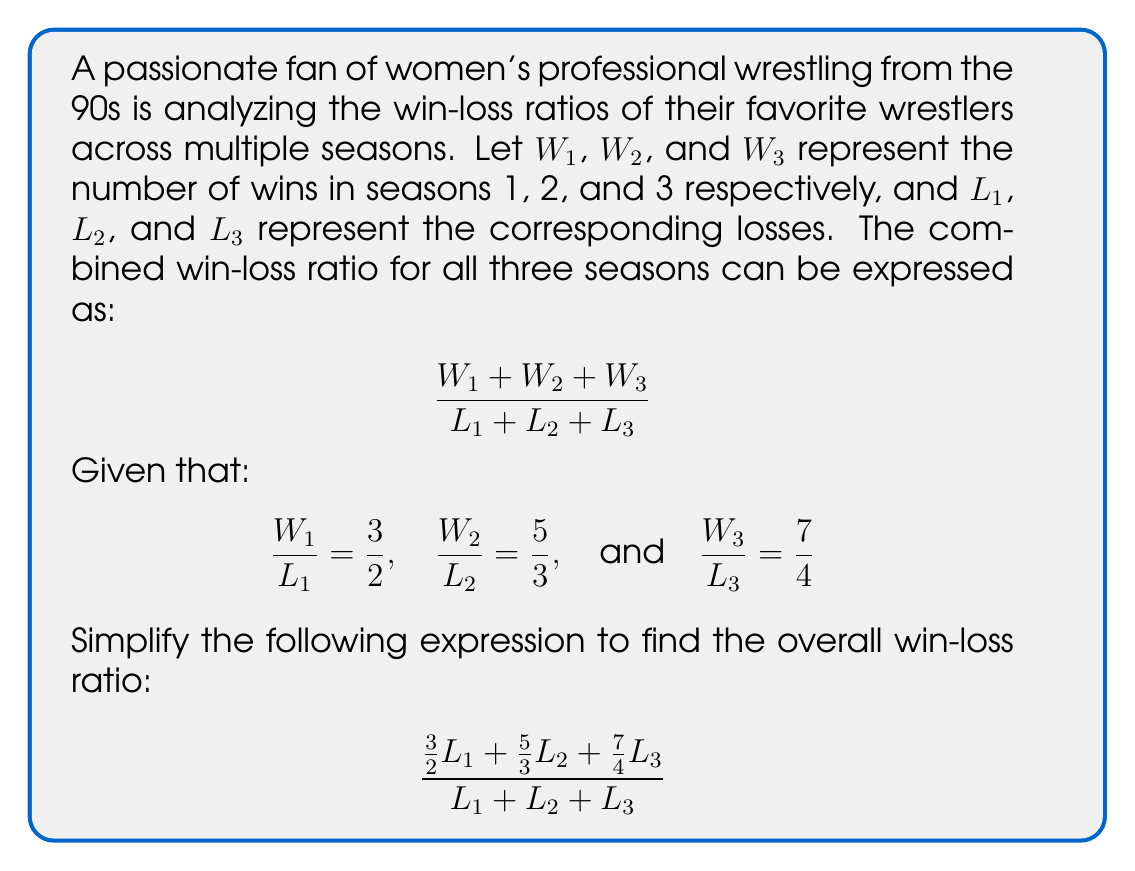What is the answer to this math problem? Let's approach this step-by-step:

1) First, we need to find a common denominator for the fractions in the numerator. The least common multiple of 2, 3, and 4 is 12. So, we'll convert each fraction:

   $\frac{3}{2} = \frac{18}{12}$
   $\frac{5}{3} = \frac{20}{12}$
   $\frac{7}{4} = \frac{21}{12}$

2) Now our expression looks like this:

   $$\frac{\frac{18}{12}L_1 + \frac{20}{12}L_2 + \frac{21}{12}L_3}{L_1 + L_2 + L_3}$$

3) We can factor out $\frac{1}{12}$ from the numerator:

   $$\frac{\frac{1}{12}(18L_1 + 20L_2 + 21L_3)}{L_1 + L_2 + L_3}$$

4) Now, we can split this into two fractions:

   $$\frac{1}{12} \cdot \frac{18L_1 + 20L_2 + 21L_3}{L_1 + L_2 + L_3}$$

5) Let's focus on simplifying the second fraction. We can factor out the greatest common factor of the coefficients (which is 1):

   $$\frac{1}{12} \cdot \frac{1(18L_1 + 20L_2 + 21L_3)}{1(L_1 + L_2 + L_3)}$$

6) This simplifies to:

   $$\frac{1}{12} \cdot \frac{18L_1 + 20L_2 + 21L_3}{L_1 + L_2 + L_3}$$

7) The numerator and denominator don't have any common factors, so this is our final simplified form.
Answer: $\frac{1}{12} \cdot \frac{18L_1 + 20L_2 + 21L_3}{L_1 + L_2 + L_3}$ 